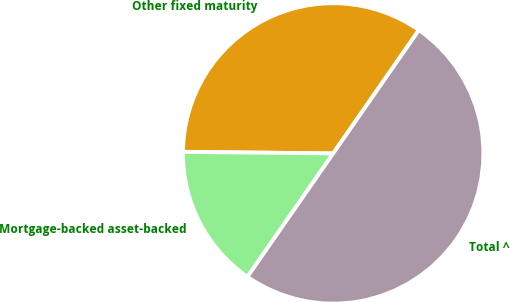<chart> <loc_0><loc_0><loc_500><loc_500><pie_chart><fcel>Other fixed maturity<fcel>Mortgage-backed asset-backed<fcel>Total ^<nl><fcel>34.5%<fcel>15.5%<fcel>50.0%<nl></chart> 